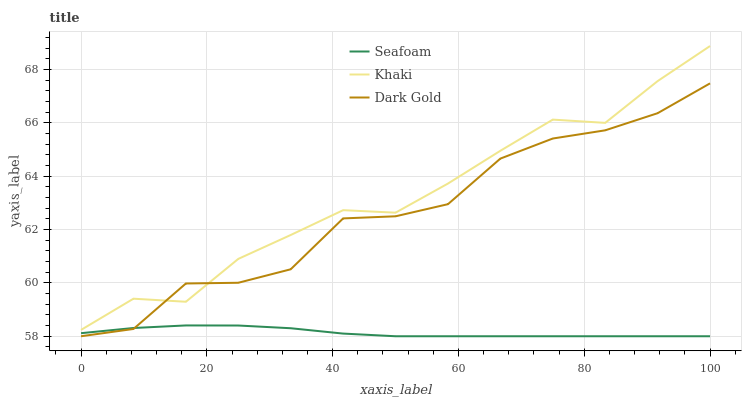Does Seafoam have the minimum area under the curve?
Answer yes or no. Yes. Does Khaki have the maximum area under the curve?
Answer yes or no. Yes. Does Dark Gold have the minimum area under the curve?
Answer yes or no. No. Does Dark Gold have the maximum area under the curve?
Answer yes or no. No. Is Seafoam the smoothest?
Answer yes or no. Yes. Is Dark Gold the roughest?
Answer yes or no. Yes. Is Dark Gold the smoothest?
Answer yes or no. No. Is Seafoam the roughest?
Answer yes or no. No. Does Seafoam have the lowest value?
Answer yes or no. Yes. Does Khaki have the highest value?
Answer yes or no. Yes. Does Dark Gold have the highest value?
Answer yes or no. No. Is Seafoam less than Khaki?
Answer yes or no. Yes. Is Khaki greater than Seafoam?
Answer yes or no. Yes. Does Seafoam intersect Dark Gold?
Answer yes or no. Yes. Is Seafoam less than Dark Gold?
Answer yes or no. No. Is Seafoam greater than Dark Gold?
Answer yes or no. No. Does Seafoam intersect Khaki?
Answer yes or no. No. 